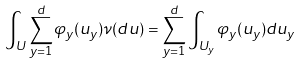Convert formula to latex. <formula><loc_0><loc_0><loc_500><loc_500>\int _ { U } \sum _ { y = 1 } ^ { d } \varphi _ { y } ( u _ { y } ) \nu ( d u ) = \sum _ { y = 1 } ^ { d } \int _ { U _ { y } } \varphi _ { y } ( u _ { y } ) d u _ { y }</formula> 